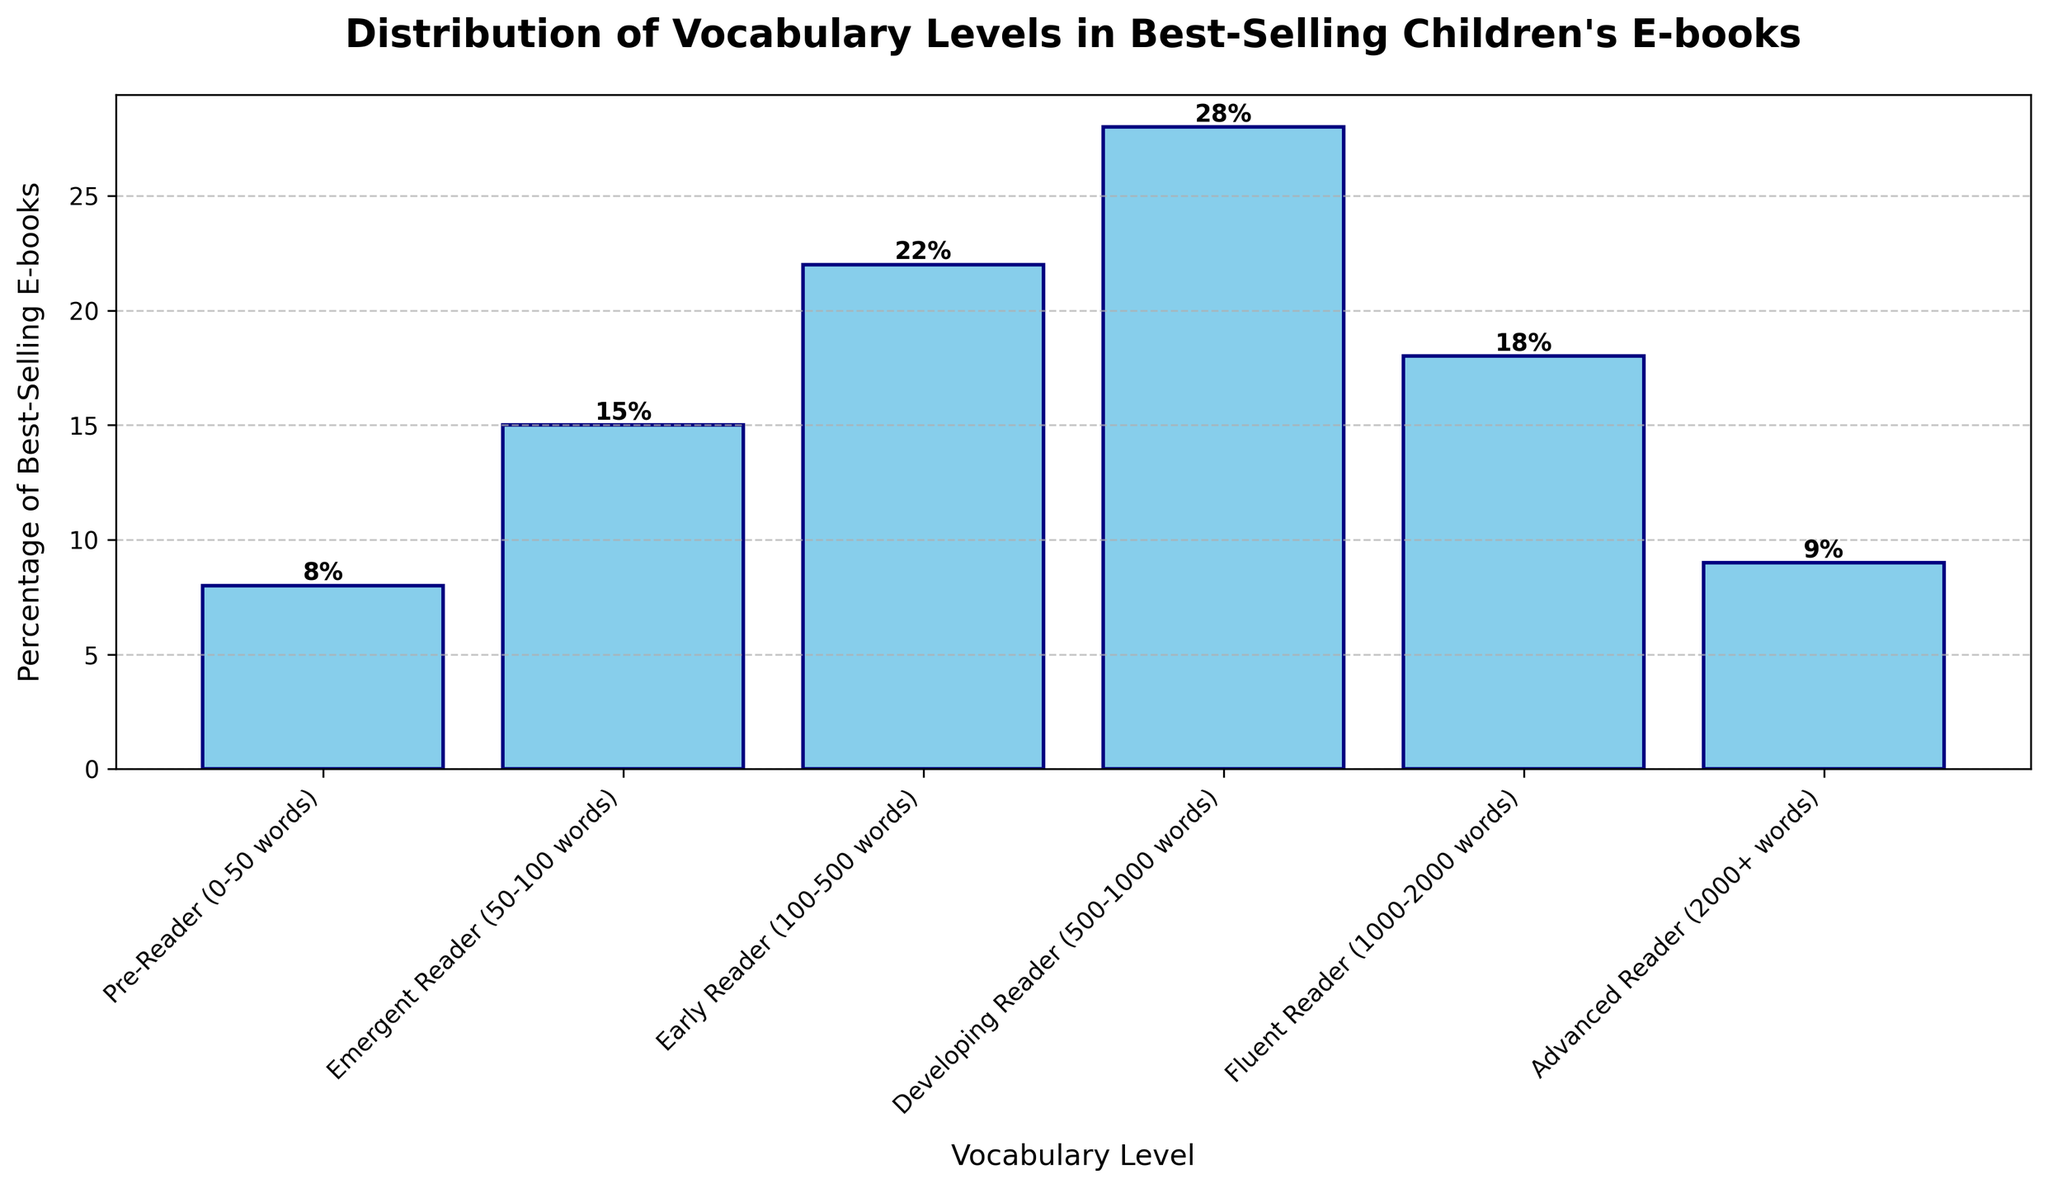What percentage of best-selling e-books fall into the 'Early Reader' category? To answer this, locate the 'Early Reader' category on the x-axis and read the corresponding bar's height, which represents the percentage. The label above the bar provides the exact value.
Answer: 22 Which vocabulary level group has the highest percentage of best-selling e-books? The group with the tallest bar represents the highest percentage. By visually comparing the heights of all the bars, the 'Developing Reader' category is the tallest.
Answer: Developing Reader What is the combined percentage of best-selling e-books in the 'Advanced Reader' and 'Pre-Reader' categories? Find the percentages for 'Advanced Reader' and 'Pre-Reader', which are 9% and 8%, respectively. Add these two values together (9 + 8).
Answer: 17 How does the percentage of 'Fluent Reader' books compare to 'Emergent Reader' books? Identify the percentages for 'Fluent Reader' (18%) and 'Emergent Reader' (15%). Compare these values (18 is greater than 15).
Answer: 'Fluent Reader' is greater What is the difference in percentage between the 'Developing Reader' and 'Fluent Reader' categories? Determine the percentages of both ('Developing Reader' is 28% and 'Fluent Reader' is 18%). Subtract the smaller percentage from the larger one (28 - 18).
Answer: 10 Which two categories have a combined percentage closest to 40%? Sum the percentages of different pairs and compare. 'Early Reader' (22%) and 'Emergent Reader' (15%) together make 37%, whereas 'Developing Reader' (28%) and 'Pre-Reader' (8%) make 36%. 'Fluent Reader' (18%) combined with 'Advanced Reader' (9%) equals 27%.
Answer: 'Early Reader' and 'Emergent Reader' Is the 'Pre-Reader' category larger than the 'Advanced Reader' category? Compare the heights of the 'Pre-Reader' (8%) and 'Advanced Reader' (9%) bars. The 'Advanced Reader' bar is slightly taller.
Answer: No What proportion of the chart does the 'Early Reader' category cover compared to the total? "Early Reader" is 22%. Calculate the total sum of percentages (8 + 15 + 22 + 28 + 18 + 9 = 100). Therefore, 'Early Reader' is 22% of the 100%.
Answer: 22% What is the median percentage value of the available vocabulary levels? Arrange the percentages in ascending order (8, 9, 15, 18, 22, 28) and find the median. The two middle values are 15 and 18. Calculate the average ((15 + 18)/2).
Answer: 16.5 Which category has the smallest representation in best-selling children's e-books? Look for the group with the shortest bar. 'Pre-Reader' at 8% is the shortest.
Answer: Pre-Reader 